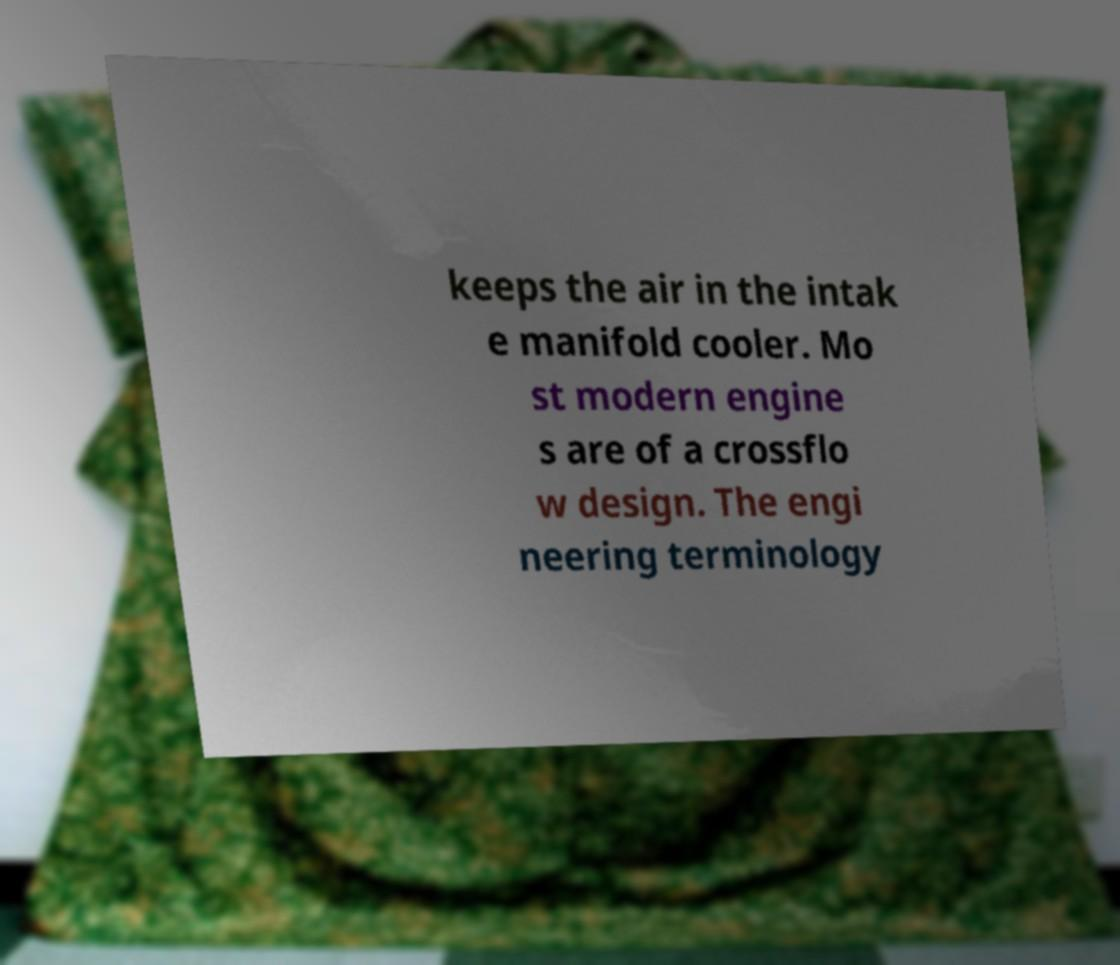Please read and relay the text visible in this image. What does it say? keeps the air in the intak e manifold cooler. Mo st modern engine s are of a crossflo w design. The engi neering terminology 